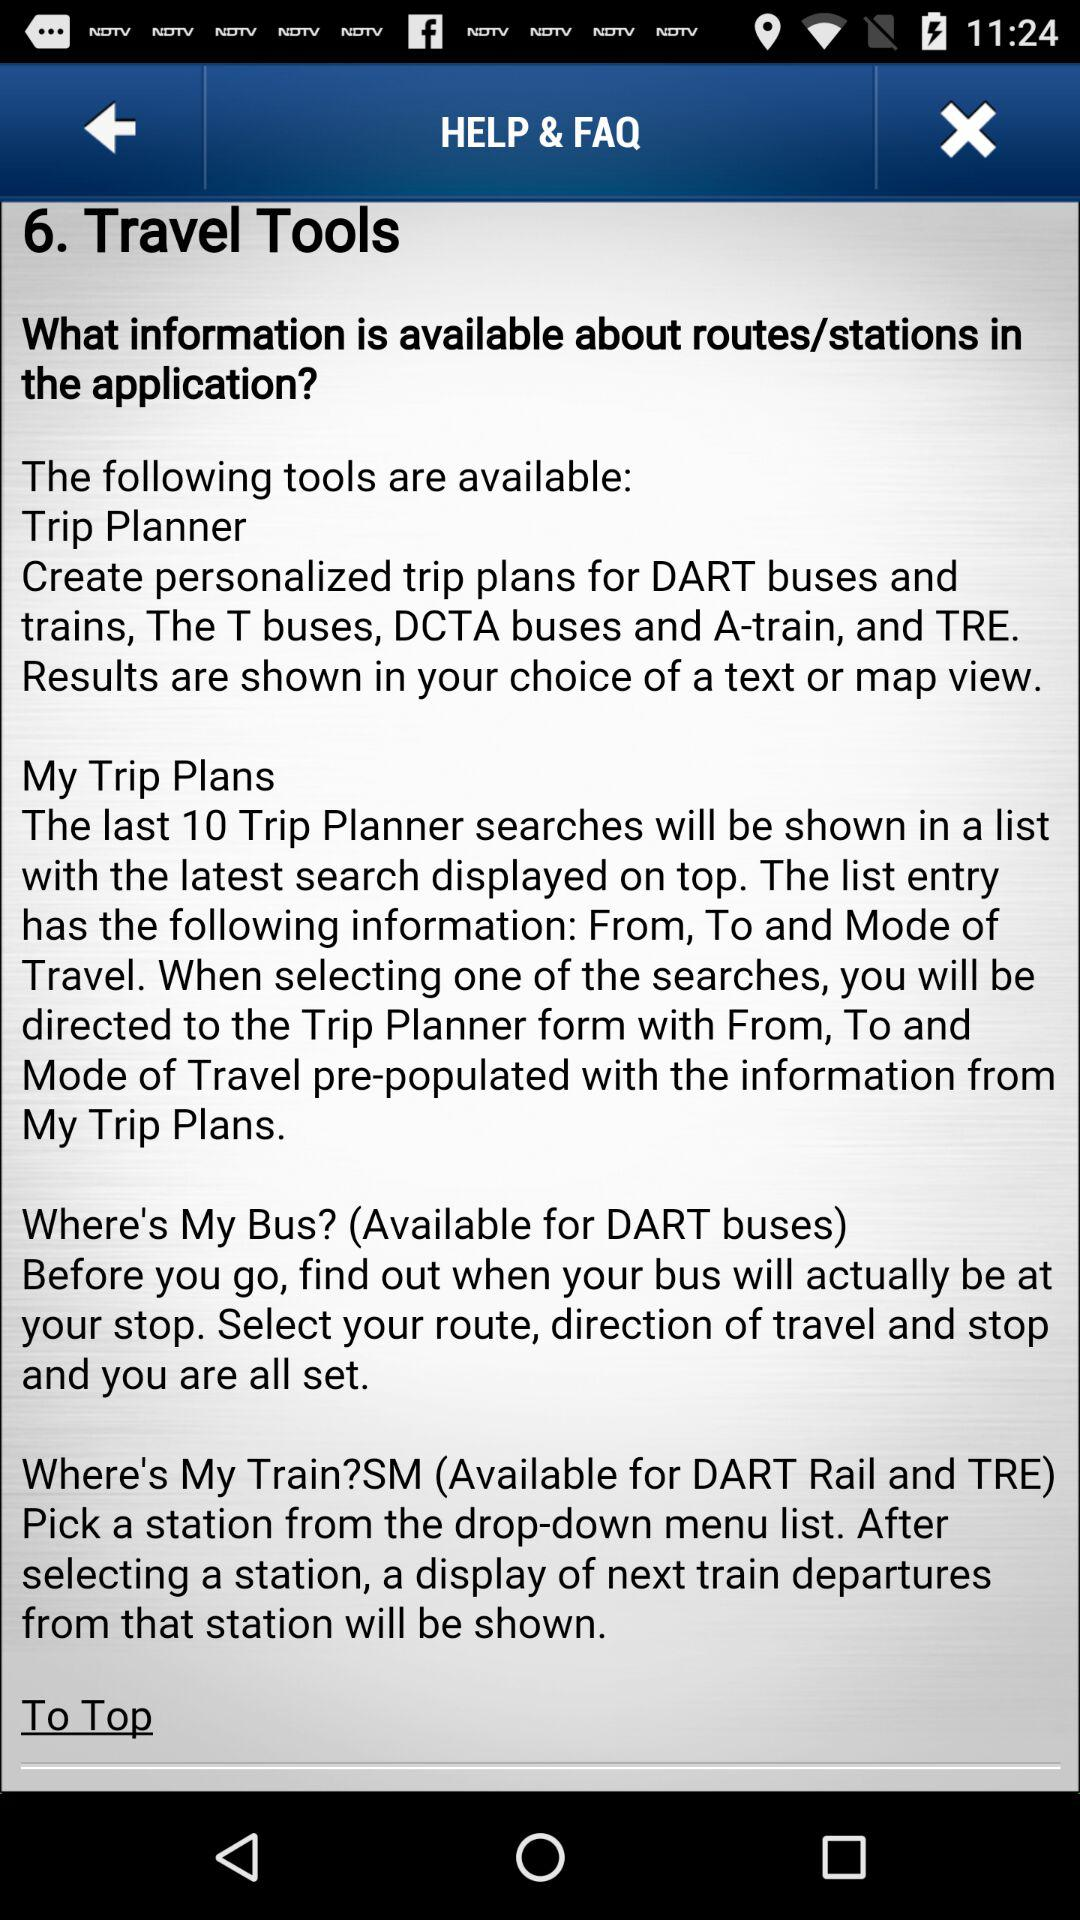How many of the tools available in the Travel Tools section are available for DART buses?
Answer the question using a single word or phrase. 2 